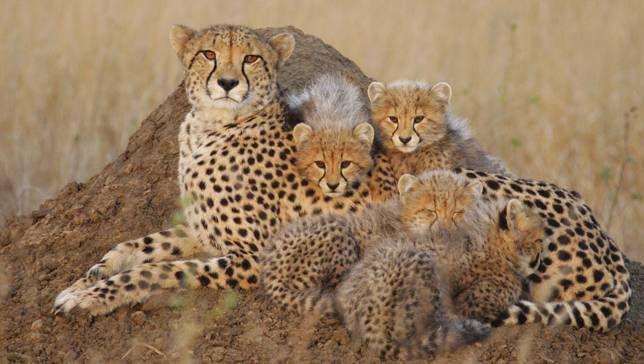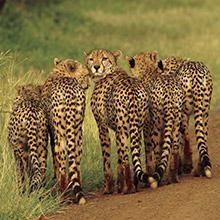The first image is the image on the left, the second image is the image on the right. Given the left and right images, does the statement "You'll notice a handful of cheetah cubs in one of the images." hold true? Answer yes or no. Yes. 